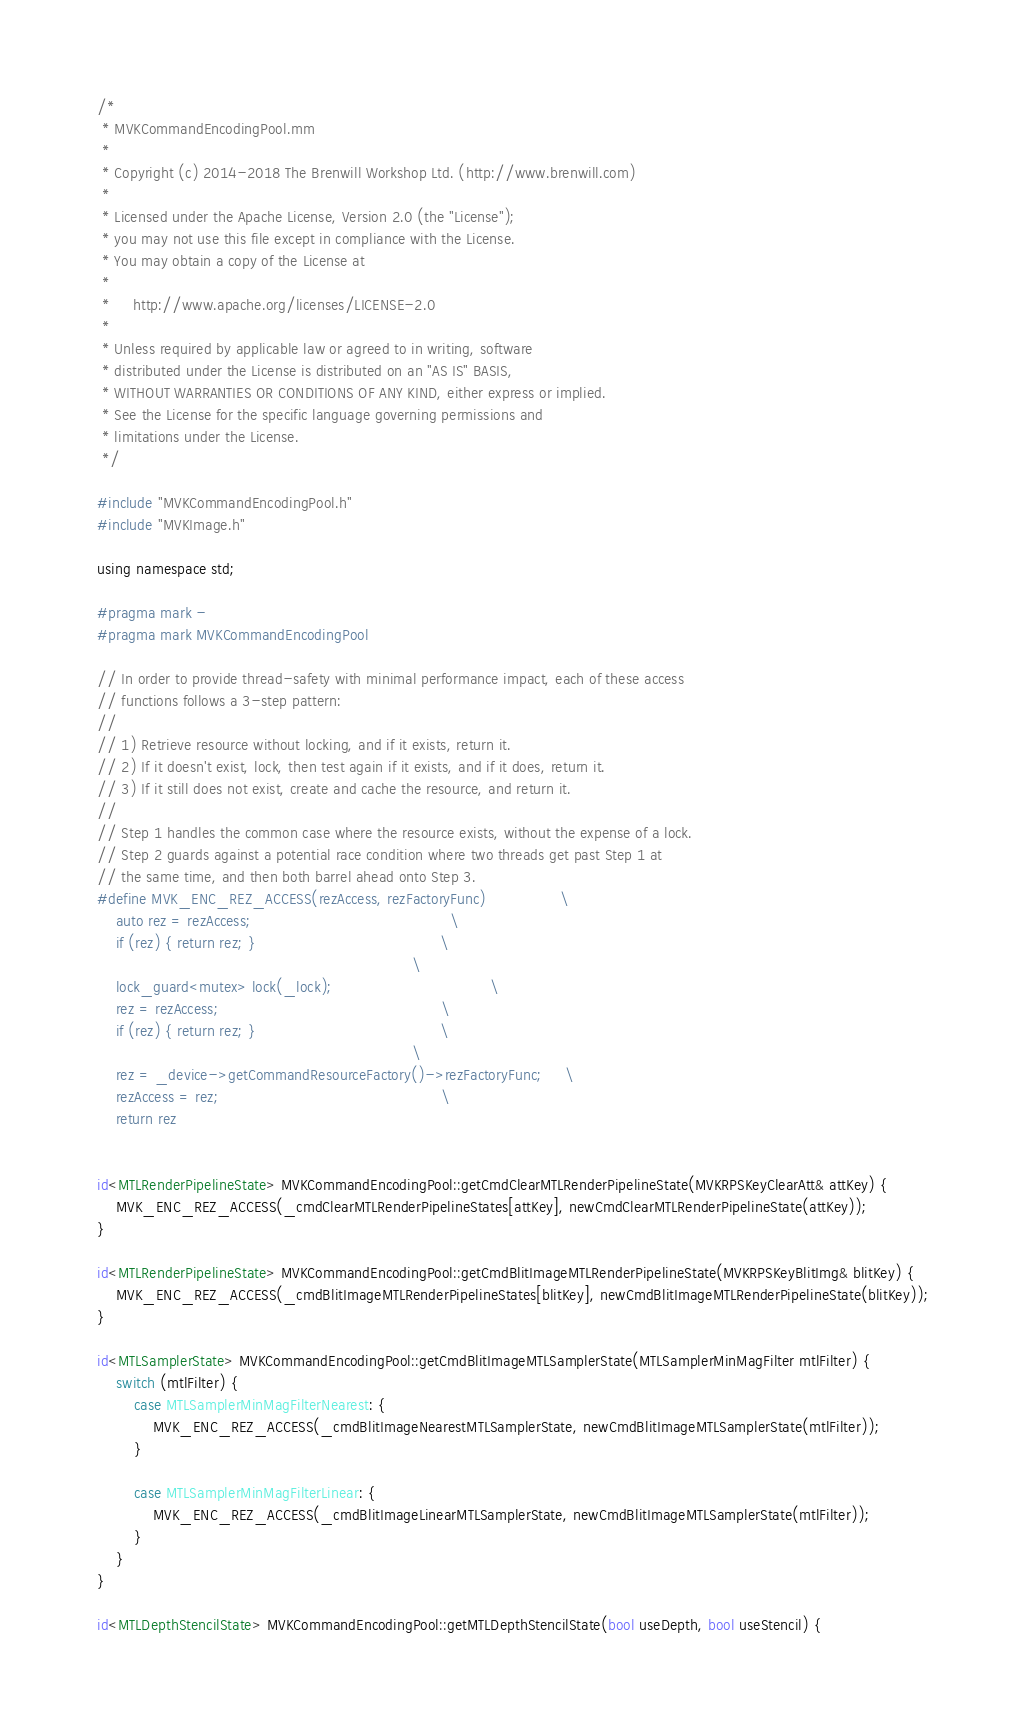<code> <loc_0><loc_0><loc_500><loc_500><_ObjectiveC_>/*
 * MVKCommandEncodingPool.mm
 *
 * Copyright (c) 2014-2018 The Brenwill Workshop Ltd. (http://www.brenwill.com)
 *
 * Licensed under the Apache License, Version 2.0 (the "License");
 * you may not use this file except in compliance with the License.
 * You may obtain a copy of the License at
 * 
 *     http://www.apache.org/licenses/LICENSE-2.0
 * 
 * Unless required by applicable law or agreed to in writing, software
 * distributed under the License is distributed on an "AS IS" BASIS,
 * WITHOUT WARRANTIES OR CONDITIONS OF ANY KIND, either express or implied.
 * See the License for the specific language governing permissions and
 * limitations under the License.
 */

#include "MVKCommandEncodingPool.h"
#include "MVKImage.h"

using namespace std;

#pragma mark -
#pragma mark MVKCommandEncodingPool

// In order to provide thread-safety with minimal performance impact, each of these access
// functions follows a 3-step pattern:
//
// 1) Retrieve resource without locking, and if it exists, return it.
// 2) If it doesn't exist, lock, then test again if it exists, and if it does, return it.
// 3) If it still does not exist, create and cache the resource, and return it.
//
// Step 1 handles the common case where the resource exists, without the expense of a lock.
// Step 2 guards against a potential race condition where two threads get past Step 1 at
// the same time, and then both barrel ahead onto Step 3.
#define MVK_ENC_REZ_ACCESS(rezAccess, rezFactoryFunc)				\
	auto rez = rezAccess;											\
	if (rez) { return rez; }										\
																	\
	lock_guard<mutex> lock(_lock);									\
	rez = rezAccess;												\
	if (rez) { return rez; }										\
																	\
	rez = _device->getCommandResourceFactory()->rezFactoryFunc;		\
	rezAccess = rez;												\
	return rez


id<MTLRenderPipelineState> MVKCommandEncodingPool::getCmdClearMTLRenderPipelineState(MVKRPSKeyClearAtt& attKey) {
	MVK_ENC_REZ_ACCESS(_cmdClearMTLRenderPipelineStates[attKey], newCmdClearMTLRenderPipelineState(attKey));
}

id<MTLRenderPipelineState> MVKCommandEncodingPool::getCmdBlitImageMTLRenderPipelineState(MVKRPSKeyBlitImg& blitKey) {
	MVK_ENC_REZ_ACCESS(_cmdBlitImageMTLRenderPipelineStates[blitKey], newCmdBlitImageMTLRenderPipelineState(blitKey));
}

id<MTLSamplerState> MVKCommandEncodingPool::getCmdBlitImageMTLSamplerState(MTLSamplerMinMagFilter mtlFilter) {
    switch (mtlFilter) {
		case MTLSamplerMinMagFilterNearest: {
			MVK_ENC_REZ_ACCESS(_cmdBlitImageNearestMTLSamplerState, newCmdBlitImageMTLSamplerState(mtlFilter));
		}

		case MTLSamplerMinMagFilterLinear: {
			MVK_ENC_REZ_ACCESS(_cmdBlitImageLinearMTLSamplerState, newCmdBlitImageMTLSamplerState(mtlFilter));
		}
    }
}

id<MTLDepthStencilState> MVKCommandEncodingPool::getMTLDepthStencilState(bool useDepth, bool useStencil) {
</code> 